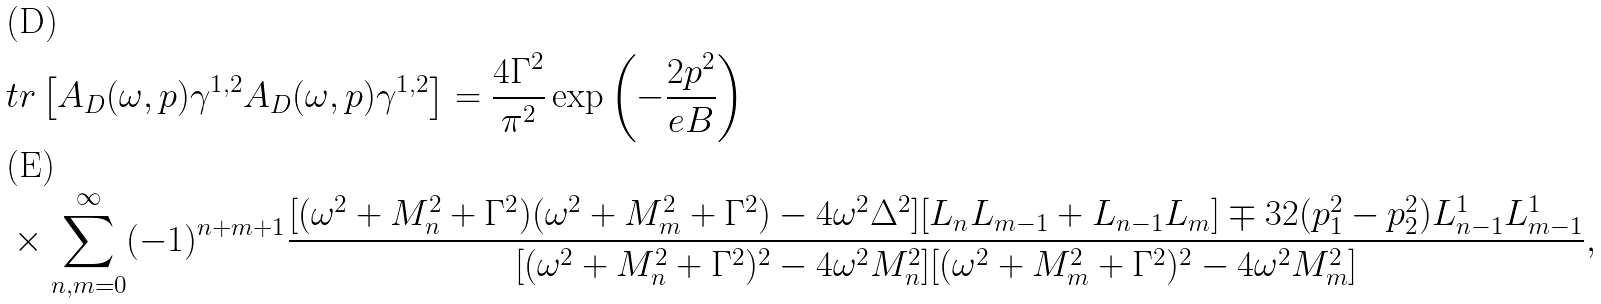<formula> <loc_0><loc_0><loc_500><loc_500>& t r \left [ A _ { D } ( \omega , { p } ) \gamma ^ { 1 , 2 } A _ { D } ( \omega , { p } ) \gamma ^ { 1 , 2 } \right ] = \frac { 4 \Gamma ^ { 2 } } { \pi ^ { 2 } } \exp \left ( - \frac { 2 p ^ { 2 } } { e B } \right ) \\ & \times \sum _ { n , m = 0 } ^ { \infty } ( - 1 ) ^ { n + m + 1 } \frac { [ ( \omega ^ { 2 } + M _ { n } ^ { 2 } + \Gamma ^ { 2 } ) ( \omega ^ { 2 } + M _ { m } ^ { 2 } + \Gamma ^ { 2 } ) - 4 \omega ^ { 2 } \Delta ^ { 2 } ] [ L _ { n } L _ { m - 1 } + L _ { n - 1 } L _ { m } ] \mp 3 2 ( p _ { 1 } ^ { 2 } - p _ { 2 } ^ { 2 } ) L _ { n - 1 } ^ { 1 } L _ { m - 1 } ^ { 1 } } { [ ( \omega ^ { 2 } + M _ { n } ^ { 2 } + \Gamma ^ { 2 } ) ^ { 2 } - 4 \omega ^ { 2 } M _ { n } ^ { 2 } ] [ ( \omega ^ { 2 } + M _ { m } ^ { 2 } + \Gamma ^ { 2 } ) ^ { 2 } - 4 \omega ^ { 2 } M _ { m } ^ { 2 } ] } ,</formula> 